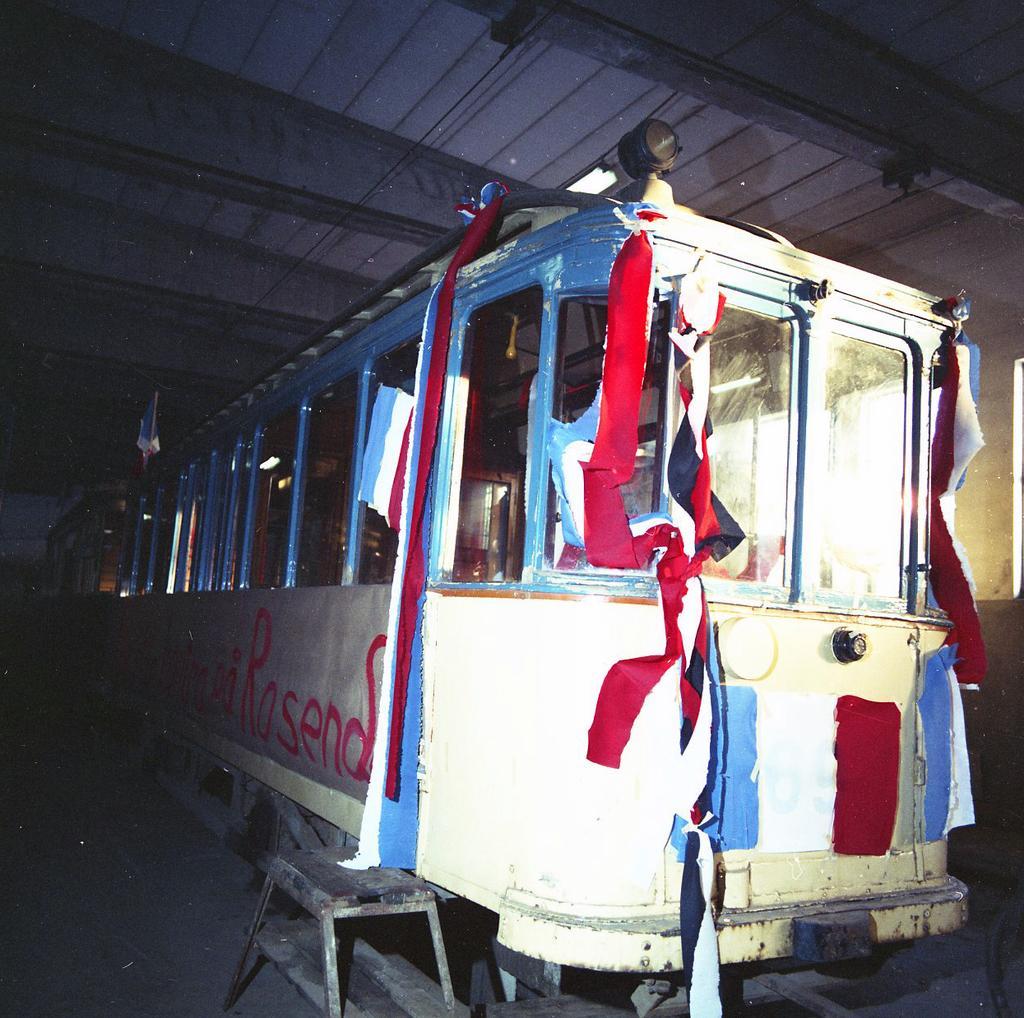Can you describe this image briefly? In this image there is the roof, there is the train, there are objects on the train, there is a banner on the train, there is text on the banner, there is the wall, there is a stool truncated towards the bottom of the image. 